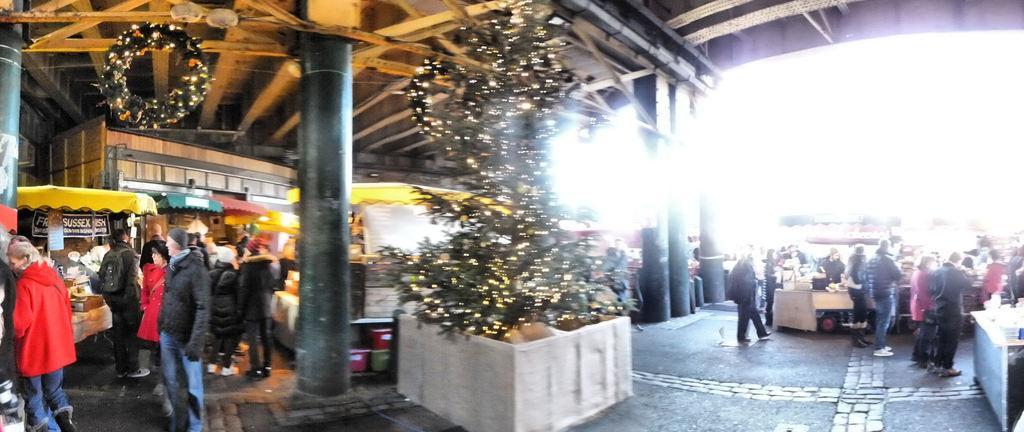Could you give a brief overview of what you see in this image? In this image I can see the ground, number of people are standing on the ground, a Christmas tree with number of lights on it, a black colored pillar and the ceiling. I can see few tents which are yellow, green and red in color. In the background I can see the sky. 